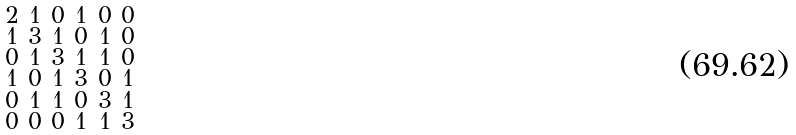<formula> <loc_0><loc_0><loc_500><loc_500>\begin{smallmatrix} 2 & 1 & 0 & 1 & 0 & 0 \\ 1 & 3 & 1 & 0 & 1 & 0 \\ 0 & 1 & 3 & 1 & 1 & 0 \\ 1 & 0 & 1 & 3 & 0 & 1 \\ 0 & 1 & 1 & 0 & 3 & 1 \\ 0 & 0 & 0 & 1 & 1 & 3 \end{smallmatrix}</formula> 